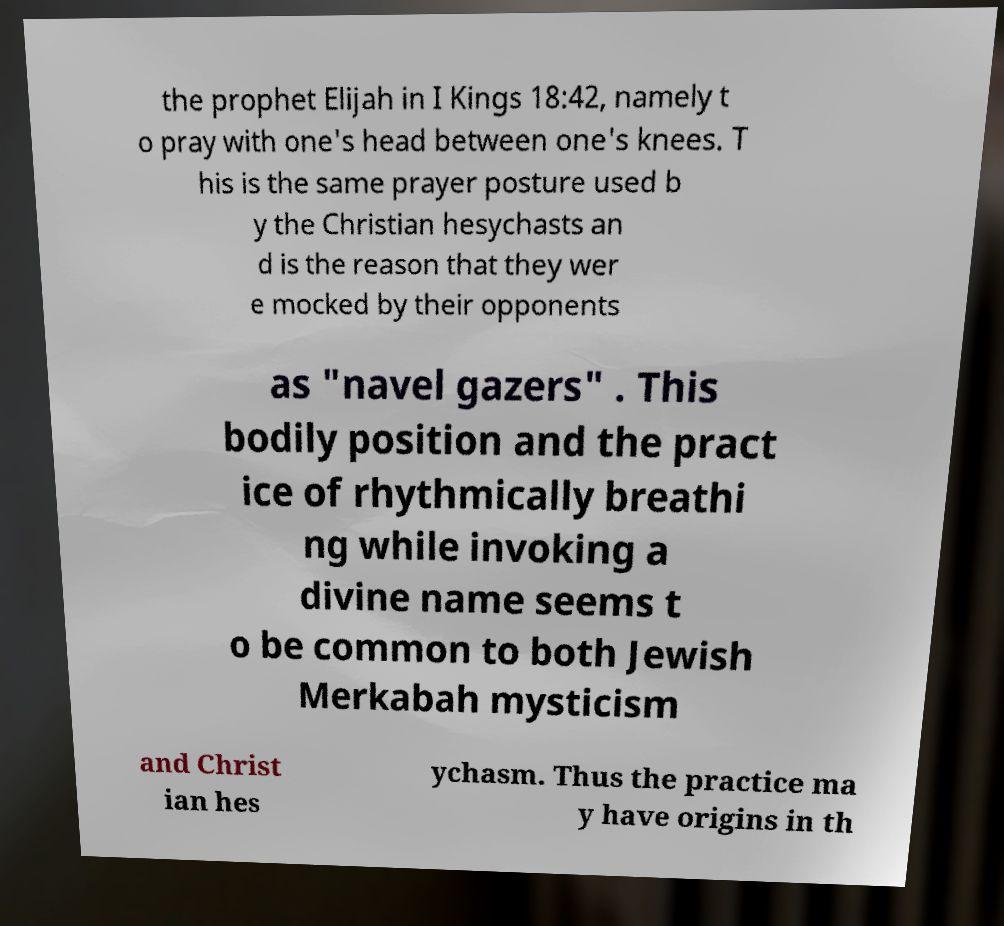Please identify and transcribe the text found in this image. the prophet Elijah in I Kings 18:42, namely t o pray with one's head between one's knees. T his is the same prayer posture used b y the Christian hesychasts an d is the reason that they wer e mocked by their opponents as "navel gazers" . This bodily position and the pract ice of rhythmically breathi ng while invoking a divine name seems t o be common to both Jewish Merkabah mysticism and Christ ian hes ychasm. Thus the practice ma y have origins in th 